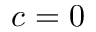<formula> <loc_0><loc_0><loc_500><loc_500>c = 0</formula> 